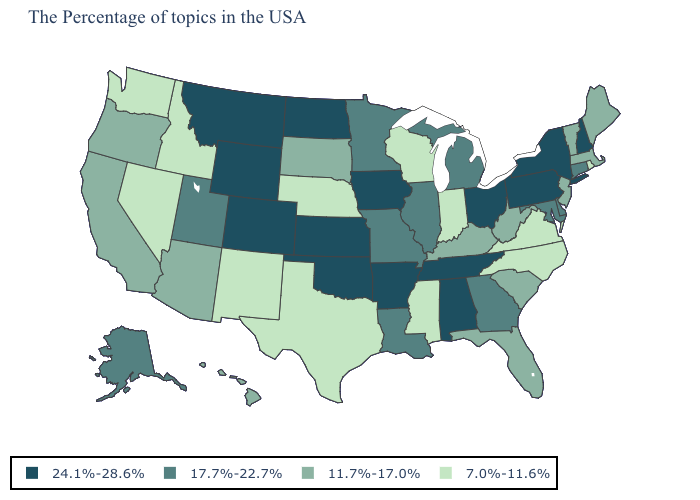What is the value of Montana?
Quick response, please. 24.1%-28.6%. Does Florida have the same value as Hawaii?
Keep it brief. Yes. Which states have the lowest value in the West?
Write a very short answer. New Mexico, Idaho, Nevada, Washington. What is the value of Montana?
Be succinct. 24.1%-28.6%. Does Washington have a lower value than North Carolina?
Keep it brief. No. How many symbols are there in the legend?
Short answer required. 4. Which states have the highest value in the USA?
Keep it brief. New Hampshire, New York, Pennsylvania, Ohio, Alabama, Tennessee, Arkansas, Iowa, Kansas, Oklahoma, North Dakota, Wyoming, Colorado, Montana. Name the states that have a value in the range 24.1%-28.6%?
Short answer required. New Hampshire, New York, Pennsylvania, Ohio, Alabama, Tennessee, Arkansas, Iowa, Kansas, Oklahoma, North Dakota, Wyoming, Colorado, Montana. Name the states that have a value in the range 17.7%-22.7%?
Keep it brief. Connecticut, Delaware, Maryland, Georgia, Michigan, Illinois, Louisiana, Missouri, Minnesota, Utah, Alaska. Name the states that have a value in the range 7.0%-11.6%?
Answer briefly. Rhode Island, Virginia, North Carolina, Indiana, Wisconsin, Mississippi, Nebraska, Texas, New Mexico, Idaho, Nevada, Washington. Which states have the highest value in the USA?
Short answer required. New Hampshire, New York, Pennsylvania, Ohio, Alabama, Tennessee, Arkansas, Iowa, Kansas, Oklahoma, North Dakota, Wyoming, Colorado, Montana. Does New Mexico have the same value as Nebraska?
Write a very short answer. Yes. What is the value of South Dakota?
Be succinct. 11.7%-17.0%. Does Rhode Island have the lowest value in the USA?
Be succinct. Yes. Name the states that have a value in the range 7.0%-11.6%?
Be succinct. Rhode Island, Virginia, North Carolina, Indiana, Wisconsin, Mississippi, Nebraska, Texas, New Mexico, Idaho, Nevada, Washington. 